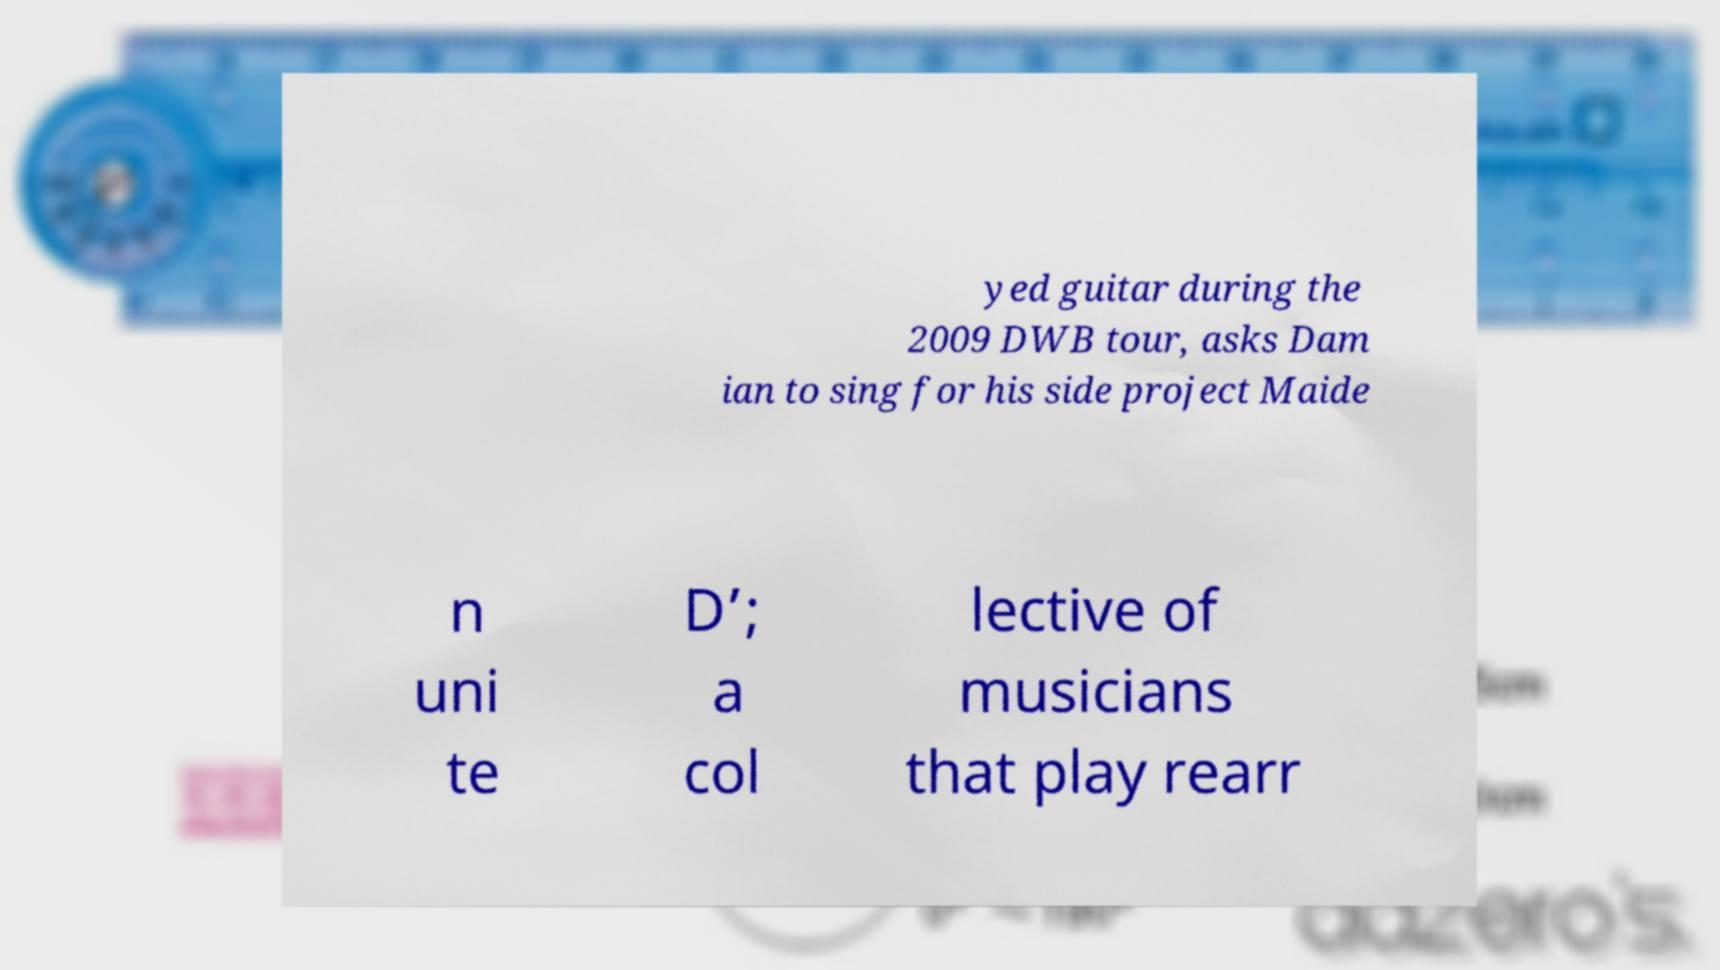Could you assist in decoding the text presented in this image and type it out clearly? yed guitar during the 2009 DWB tour, asks Dam ian to sing for his side project Maide n uni te D’; a col lective of musicians that play rearr 